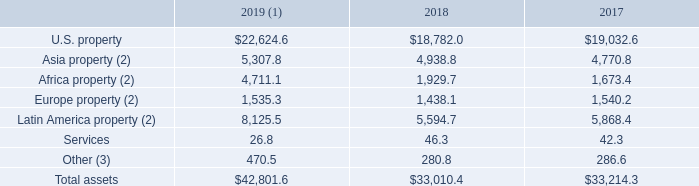AMERICAN TOWER CORPORATION AND SUBSIDIARIES NOTES TO CONSOLIDATED FINANCIAL STATEMENTS (Tabular amounts in millions, unless otherwise disclosed)
Additional information relating to the total assets of the Company’s operating segments is as follows for the years ended December 31,:
(1) Total assets in each of the Company’s property segments includes the Right-of-use asset recognized in connection with the Company’s adoption of the new lease accounting standard.
(2) Balances are translated at the applicable period end exchange rate, which may impact comparability between periods.
(3) Balances include corporate assets such as cash and cash equivalents, certain tangible and intangible assets and income tax accounts that have not been allocated to specific segments.
What did the total assets in each property segment include? The right-of-use asset recognized in connection with the company’s adoption of the new lease accounting standard. What do balances include? Corporate assets such as cash and cash equivalents, certain tangible and intangible assets and income tax accounts that have not been allocated to specific segments. What were the assets from Africa property in 2019?
Answer scale should be: million. 4,711.1. What was the change in assets from U.S. property between 2018 and 2019?
Answer scale should be: million. $22,624.6-$18,782.0
Answer: 3842.6. How many years did the total assets exceed $40,000 million? 2019
Answer: 1. How many years did other assets exceed $300 million? 2019
Answer: 1. 